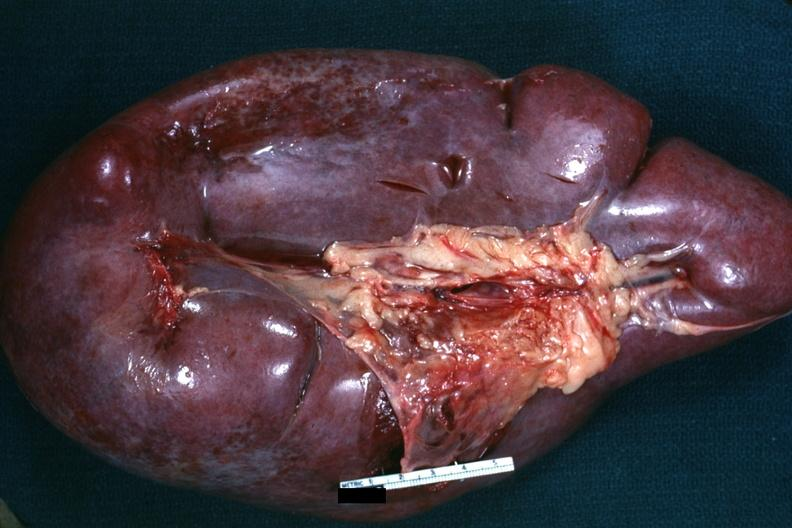does this image show external view of massively enlarged spleen?
Answer the question using a single word or phrase. Yes 